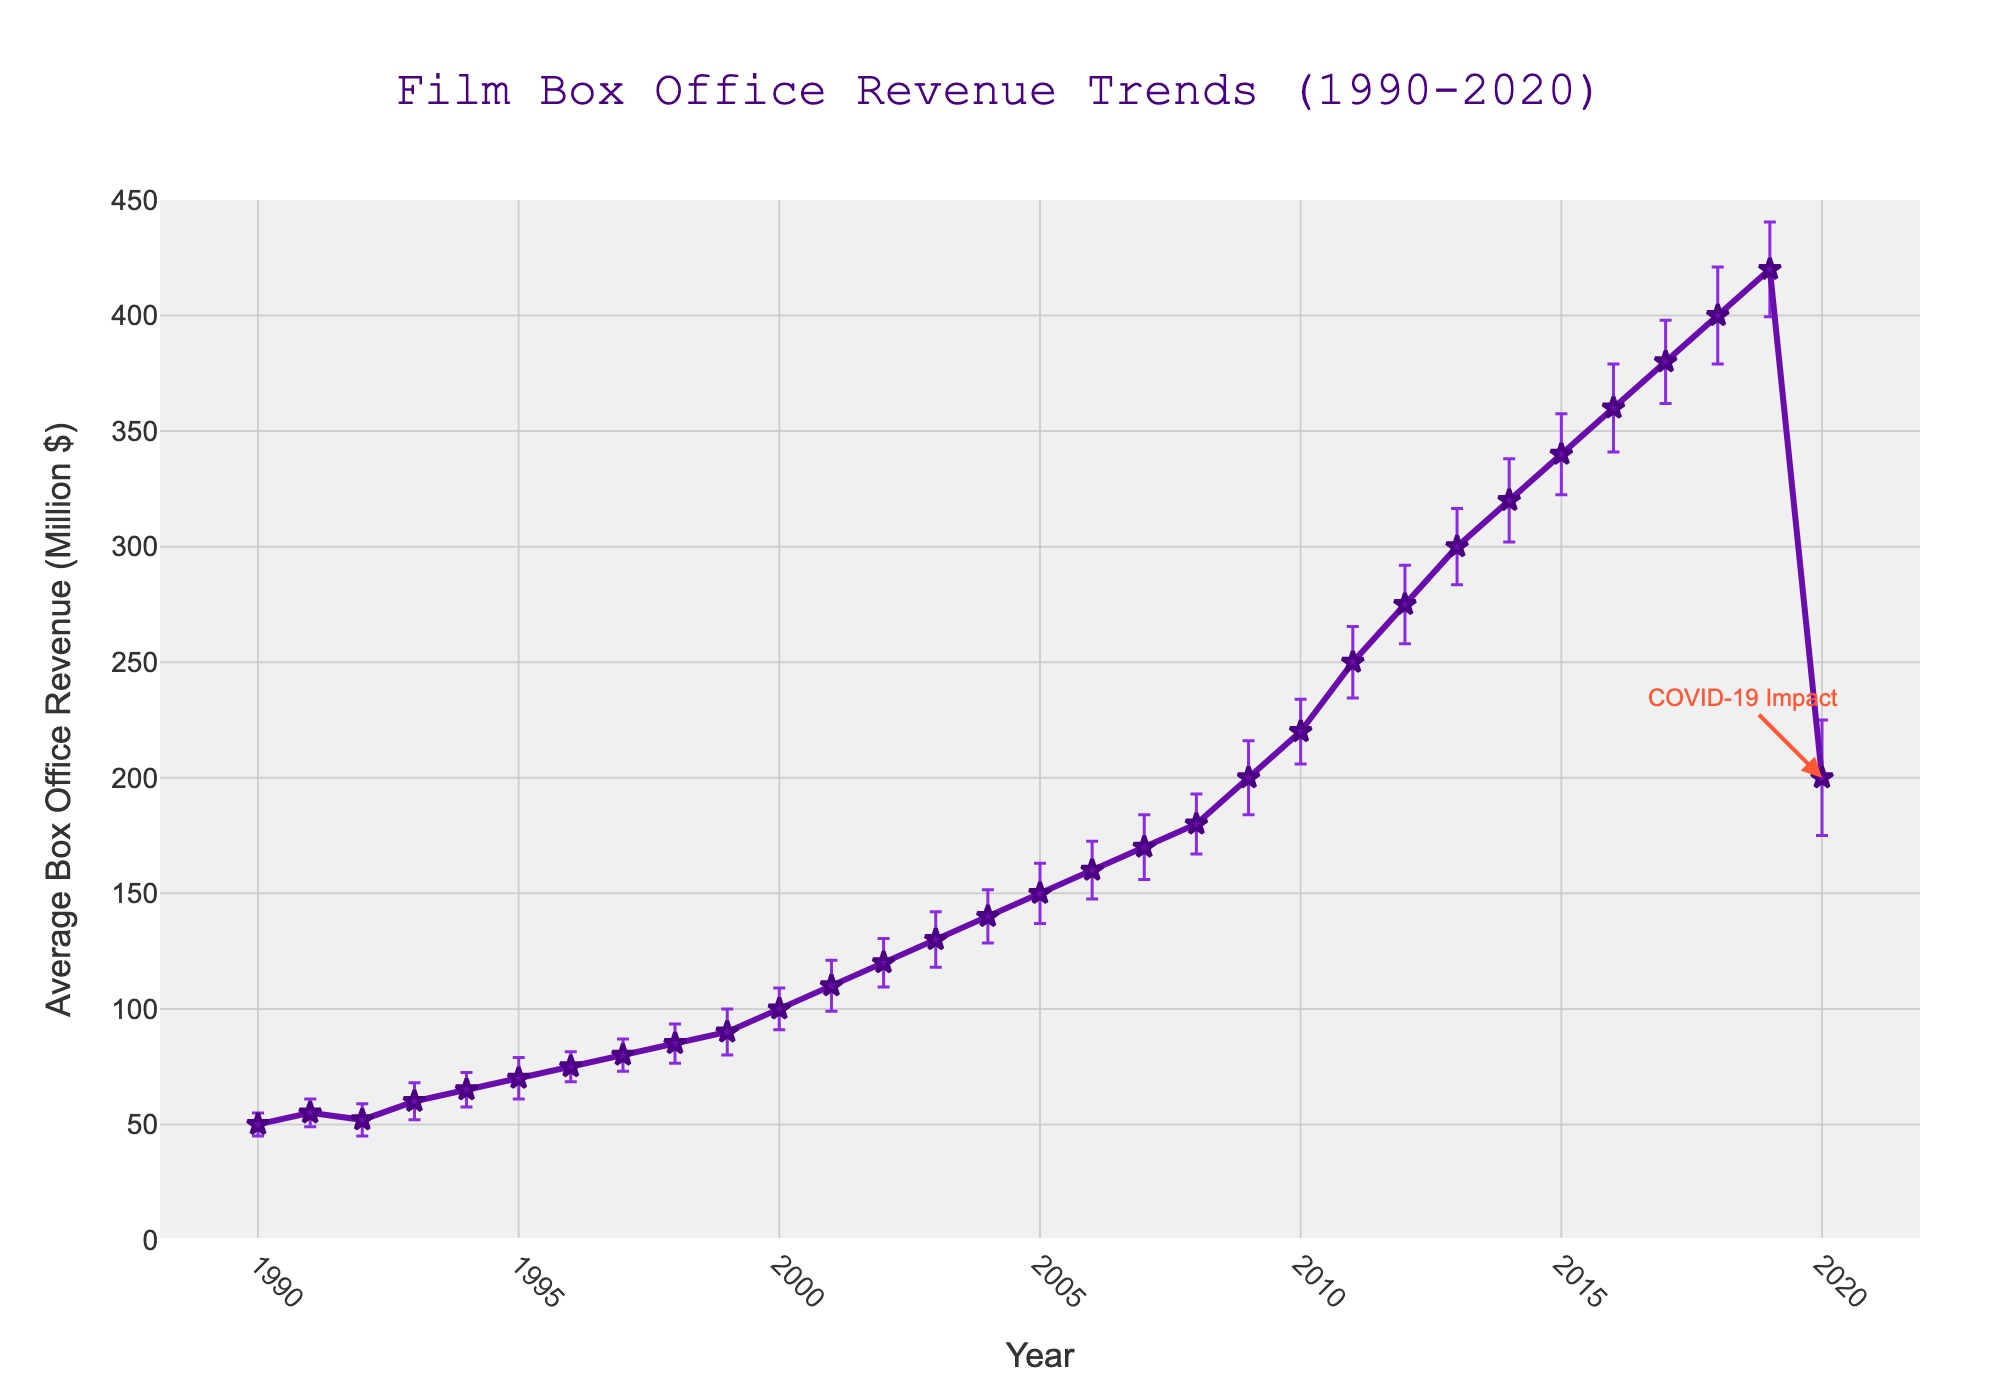What is the title of the plot? The title is usually displayed at the top of the plot. According to the information provided, the title of this plot is: "Film Box Office Revenue Trends (1990-2020)"
Answer: Film Box Office Revenue Trends (1990-2020) What is the average box office revenue in the year 2010? To find this, we look at the data point corresponding to the year 2010 on the x-axis and read the y-axis value. The average box office revenue for 2010 is labeled as 220 million dollars on the plot.
Answer: 220 million dollars What trend do you observe in the box office revenues from 1990 to 2020? Looking at the line plot, there is a general upward trend in box office revenues from 1990 to 2019. However, in 2020 this trend sharply reverses due to the impact of COVID-19.
Answer: Upward trend until 2019, then a sharp decline in 2020 Which year has the highest average box office revenue, and what is the value? We find the highest point on the y-axis, which corresponds to the year 2019. The highest average box office revenue is 420 million dollars.
Answer: 2019, 420 million dollars What is the standard deviation in the year 2020, and what does this imply? According to the data, the standard deviation for 2020 is 25. This high value implies that there was significant variability in box office revenues in 2020, likely due to the erratic impact of the COVID-19 pandemic on the film industry.
Answer: 25, significant variability How did the average box office revenue change from 1990 to 1991? The average revenue in 1990 is 50 million dollars and in 1991 is 55 million dollars. The change is 55 - 50 = 5 million dollars.
Answer: Increased by 5 million dollars Which year experienced the largest drop in average box office revenue compared to the previous year? By observing the plot, the largest drop occurs between 2019 and 2020. The revenue dropped from 420 million dollars in 2019 to 200 million dollars in 2020.
Answer: 2020 What years show a clear and distinguishable impact on box office revenue, and what event is indicated in the plot? The year 2020 shows a clear and distinguishable impact with a major drop in revenue. The annotation on the plot indicates this decline is due to the "COVID-19 Impact".
Answer: 2020, COVID-19 What is the average box office revenue for the decade of 2000-2009? Add the average revenues from 2000 to 2009 and divide by the number of years (10). (100+110+120+130+140+150+160+170+180+200) / 10 = 146 million dollars.
Answer: 146 million dollars Compare the average box office revenues of 1995 and 2005. Which year had a higher revenue, and by how much? According to the data, 1995 has an average revenue of 70 million dollars, and 2005 has 150 million dollars. 150 - 70 = 80 million dollars. Therefore, 2005 had a higher revenue by 80 million dollars.
Answer: 2005, by 80 million dollars 